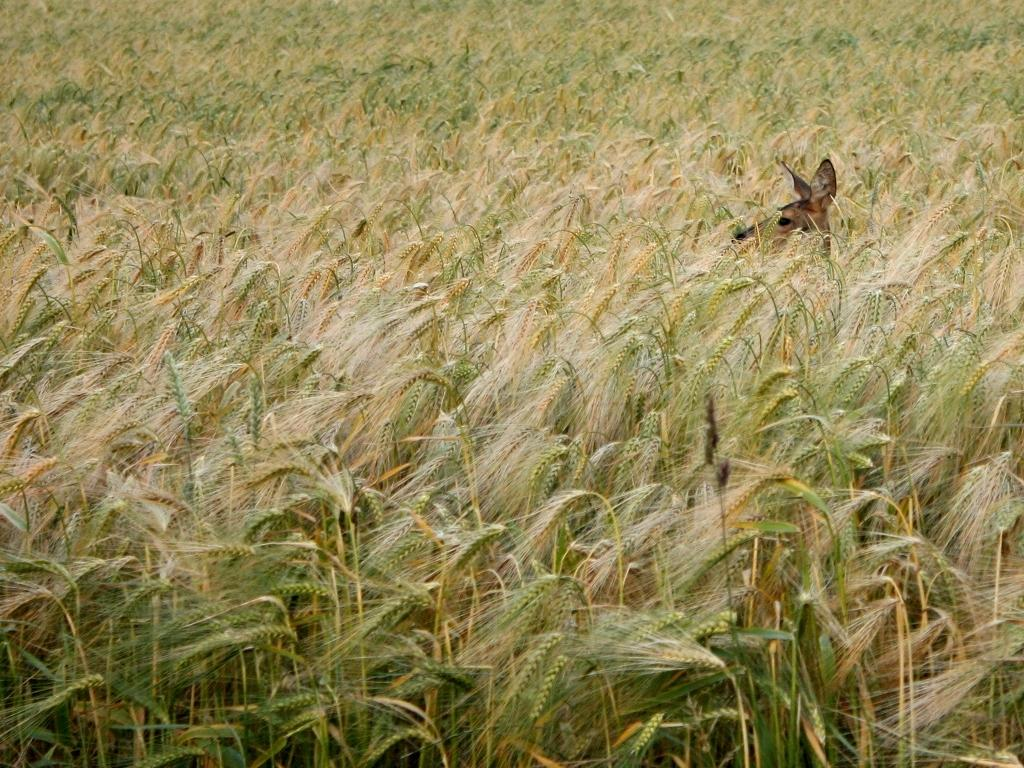What type of living organism can be seen in the image? There is an animal in the image. What other elements are present in the image besides the animal? There are plants in the image. What question is being asked by the animal in the image? There is no indication in the image that the animal is asking a question. 